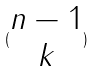<formula> <loc_0><loc_0><loc_500><loc_500>( \begin{matrix} n - 1 \\ k \end{matrix} )</formula> 